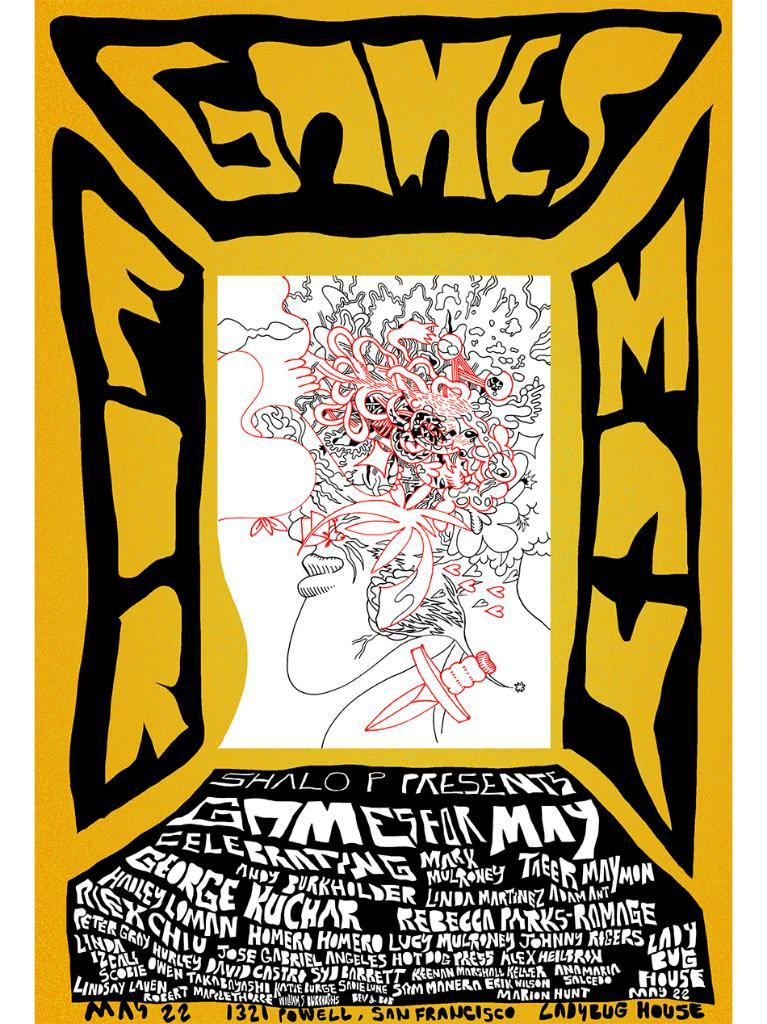What is featured on the poster in the image? There is a poster in the image, which contains a sketch. What else is present on the poster besides the sketch? The poster contains text. What type of bone can be seen flying like a kite in the image? There is no bone or kite present in the image; it only features a poster with a sketch and text. 